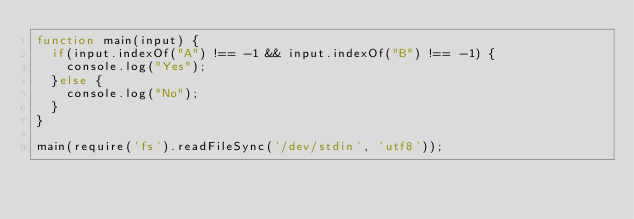Convert code to text. <code><loc_0><loc_0><loc_500><loc_500><_JavaScript_>function main(input) {
  if(input.indexOf("A") !== -1 && input.indexOf("B") !== -1) {
    console.log("Yes");
  }else {
    console.log("No");
  }
}
 
main(require('fs').readFileSync('/dev/stdin', 'utf8'));</code> 